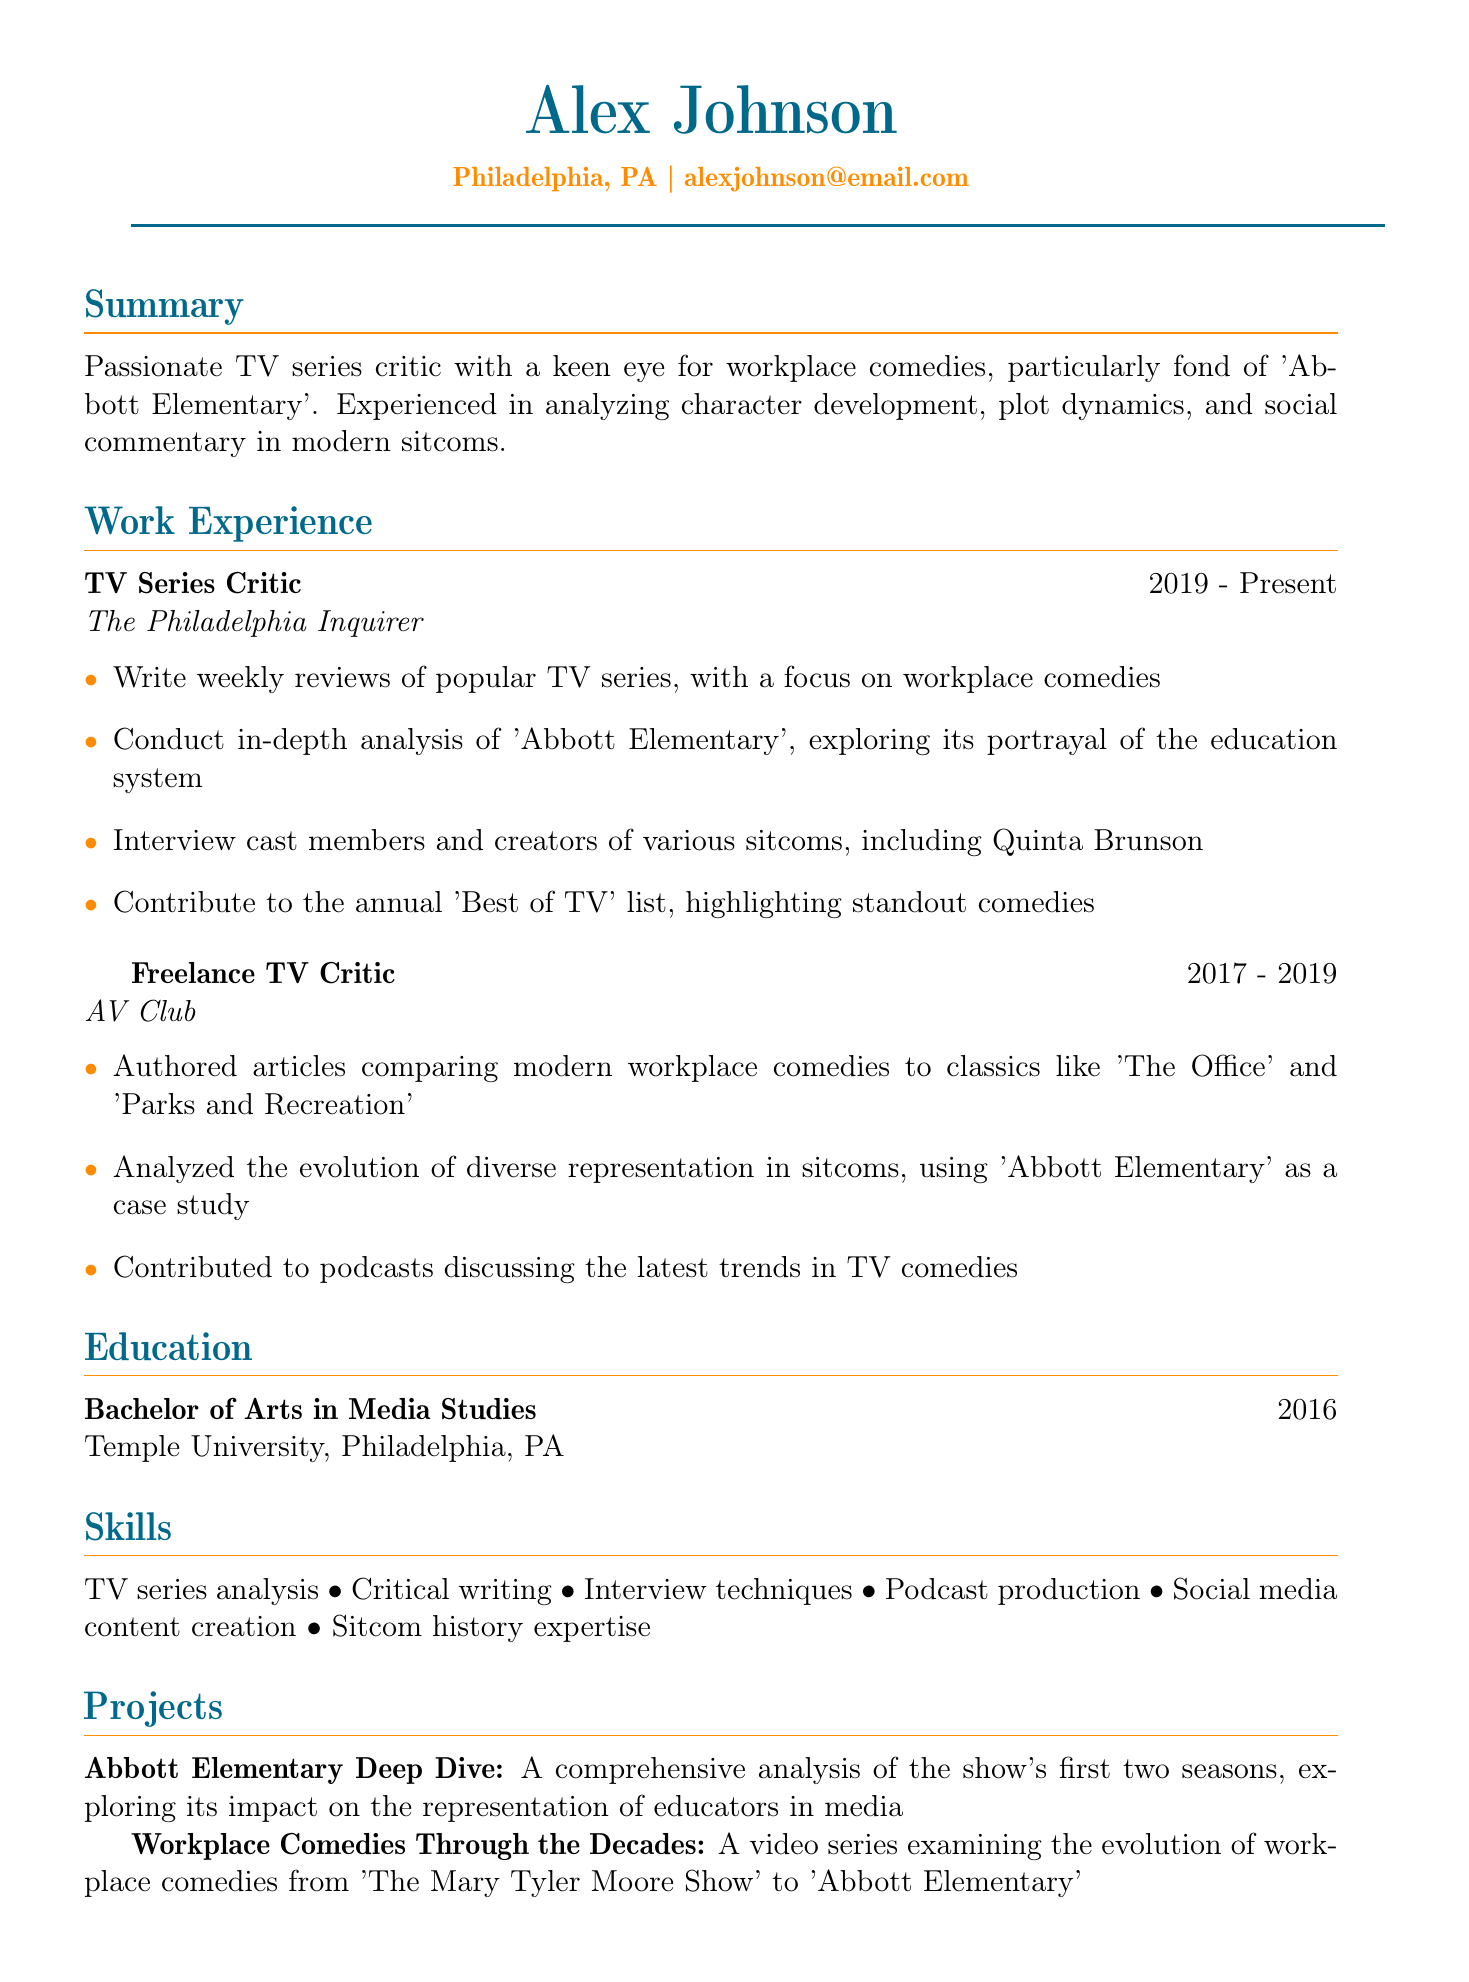What is the name of the critic? The document provides the name of the critic at the top section, which is Alex Johnson.
Answer: Alex Johnson What company does Alex work for currently? The document lists The Philadelphia Inquirer as the company Alex Johnson currently works for in the work experience section.
Answer: The Philadelphia Inquirer In which year did Alex graduate? The education section states the graduation year as 2016.
Answer: 2016 What award did Alex receive in 2022? The awards section specifies the award received as Excellence in TV Criticism from the Philadelphia Press Association.
Answer: Excellence in TV Criticism Which TV series does Alex particularly analyze? The summary section mentions a specific show that Alex is particularly fond of, which is 'Abbott Elementary'.
Answer: 'Abbott Elementary' What type of analysis is a project Alex worked on? The document mentions the project Abbott Elementary Deep Dive, pertaining to the analysis of the representation of educators in media.
Answer: A comprehensive analysis How many years of experience does Alex have as a TV Series Critic? The work experience shows a duration of 4 years from 2019 to present.
Answer: 4 years Which two classics does Alex compare modern workplace comedies to? In the responsibilities of the freelance role, the document lists 'The Office' and 'Parks and Recreation' as the classics for comparison.
Answer: 'The Office' and 'Parks and Recreation' What is the degree Alex holds? The education section clearly states Alex's degree is a Bachelor of Arts in Media Studies.
Answer: Bachelor of Arts in Media Studies 